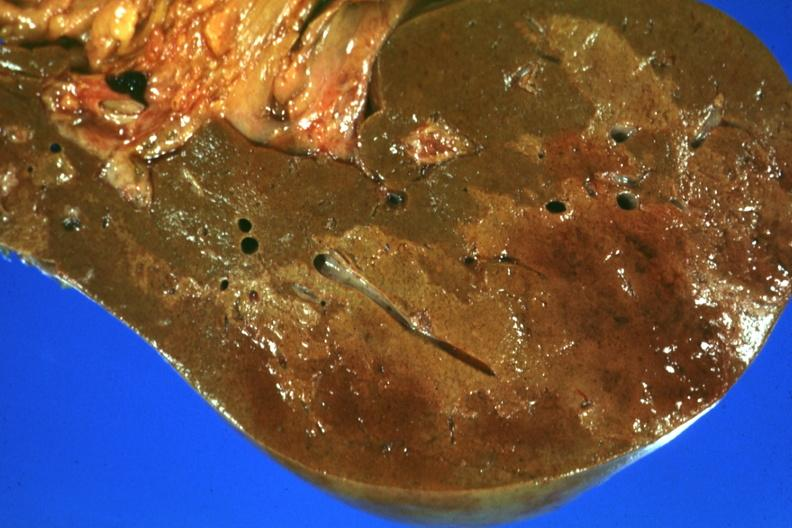s liver present?
Answer the question using a single word or phrase. Yes 